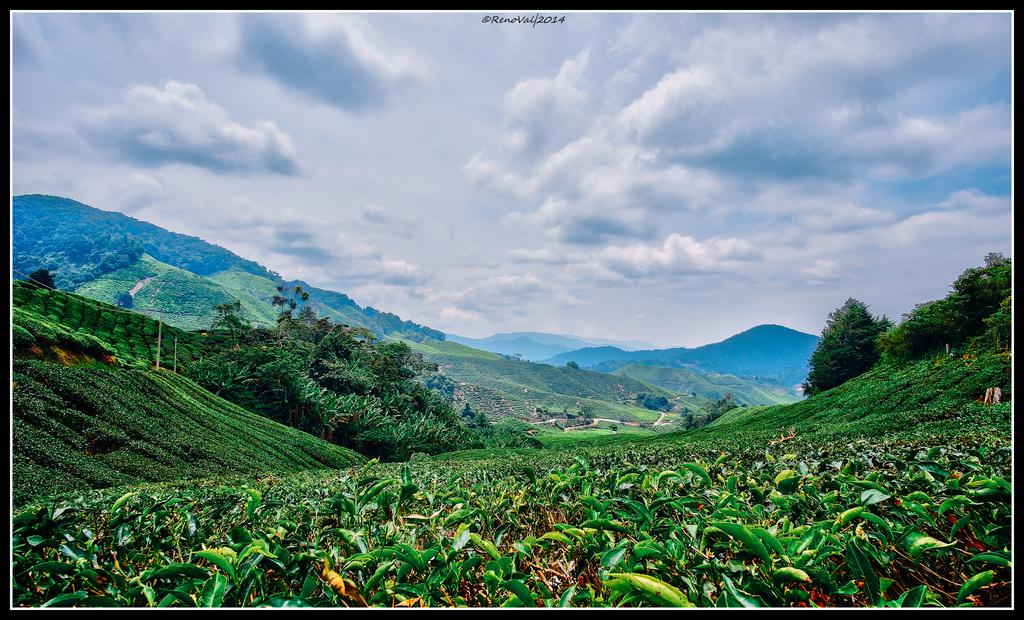What type of living organisms can be seen in the image? Plants and trees are visible in the image. What is the color of the plants and trees in the image? The plants and trees are in green color. What can be seen in the background of the image? There are mountains visible in the background of the image. What is the color of the sky in the image? The sky is in blue and white color. What type of representative is present in the image? There is no representative present in the image; it features plants, trees, mountains, and the sky. Can you tell me how many rats are visible in the image? There are no rats present in the image. 